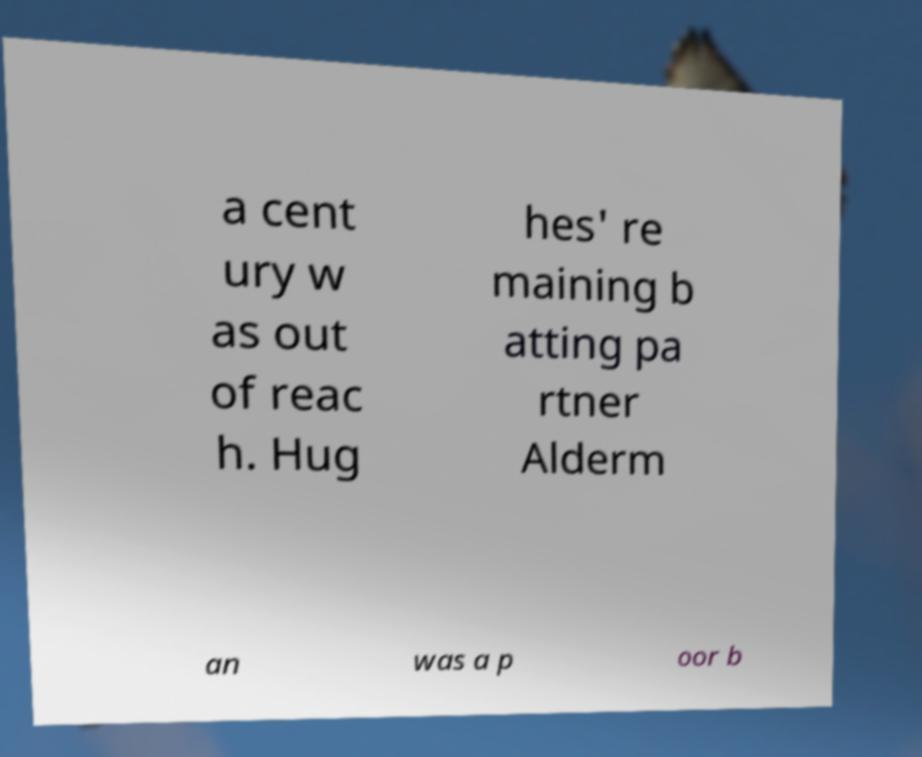There's text embedded in this image that I need extracted. Can you transcribe it verbatim? a cent ury w as out of reac h. Hug hes' re maining b atting pa rtner Alderm an was a p oor b 